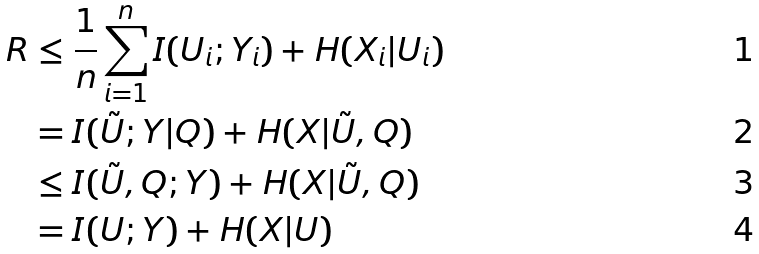<formula> <loc_0><loc_0><loc_500><loc_500>R & \leq \frac { 1 } { n } \sum _ { i = 1 } ^ { n } I ( U _ { i } ; Y _ { i } ) + H ( X _ { i } | U _ { i } ) \\ & = I ( \tilde { U } ; Y | Q ) + H ( X | \tilde { U } , Q ) \\ & \leq I ( \tilde { U } , Q ; Y ) + H ( X | \tilde { U } , Q ) \\ & = I ( U ; Y ) + H ( X | U )</formula> 